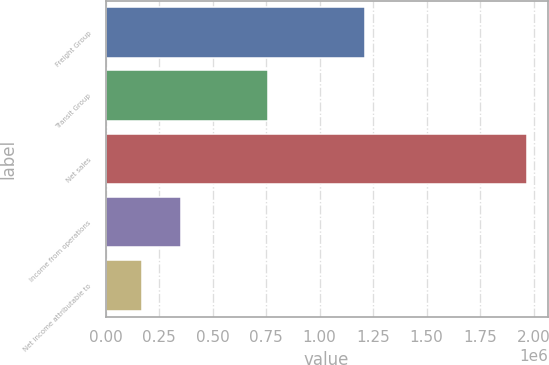<chart> <loc_0><loc_0><loc_500><loc_500><bar_chart><fcel>Freight Group<fcel>Transit Group<fcel>Net sales<fcel>Income from operations<fcel>Net income attributable to<nl><fcel>1.21006e+06<fcel>757578<fcel>1.96764e+06<fcel>350296<fcel>170591<nl></chart> 